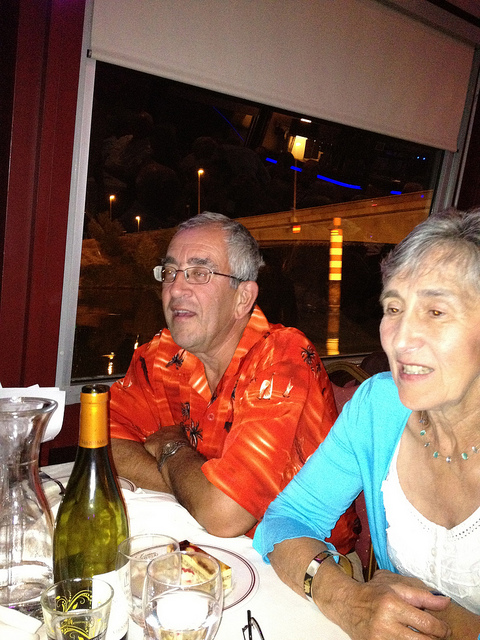Please provide a short description for this region: [0.29, 0.32, 0.66, 0.85]. A man wearing a vibrant red shirt, seemingly enjoying a moment at a dinner table. 